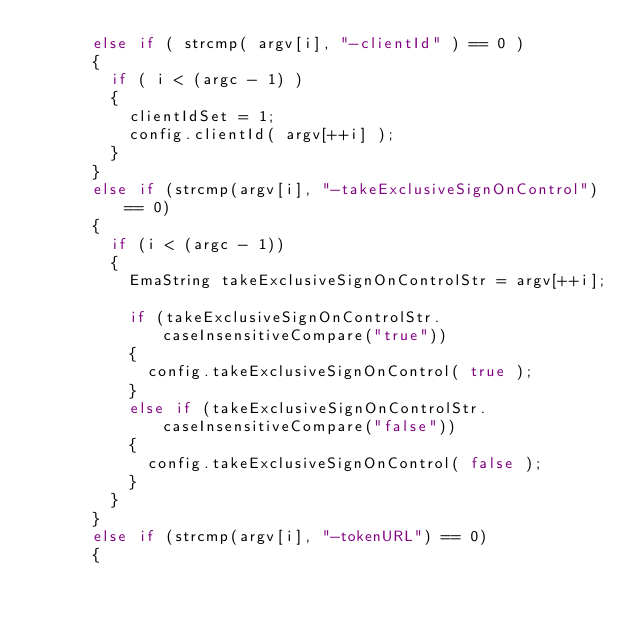<code> <loc_0><loc_0><loc_500><loc_500><_C++_>			else if ( strcmp( argv[i], "-clientId" ) == 0 )
			{
				if ( i < (argc - 1) )
				{
					clientIdSet = 1;
					config.clientId( argv[++i] );
				}
			}
			else if (strcmp(argv[i], "-takeExclusiveSignOnControl") == 0)
			{
				if (i < (argc - 1))
				{
					EmaString takeExclusiveSignOnControlStr = argv[++i];

					if (takeExclusiveSignOnControlStr.caseInsensitiveCompare("true"))
					{
						config.takeExclusiveSignOnControl( true );
					}
					else if (takeExclusiveSignOnControlStr.caseInsensitiveCompare("false"))
					{
						config.takeExclusiveSignOnControl( false );
					}
				}
			}
			else if (strcmp(argv[i], "-tokenURL") == 0)
			{</code> 